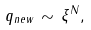Convert formula to latex. <formula><loc_0><loc_0><loc_500><loc_500>q _ { n e w } \, \sim \, \xi ^ { N } ,</formula> 